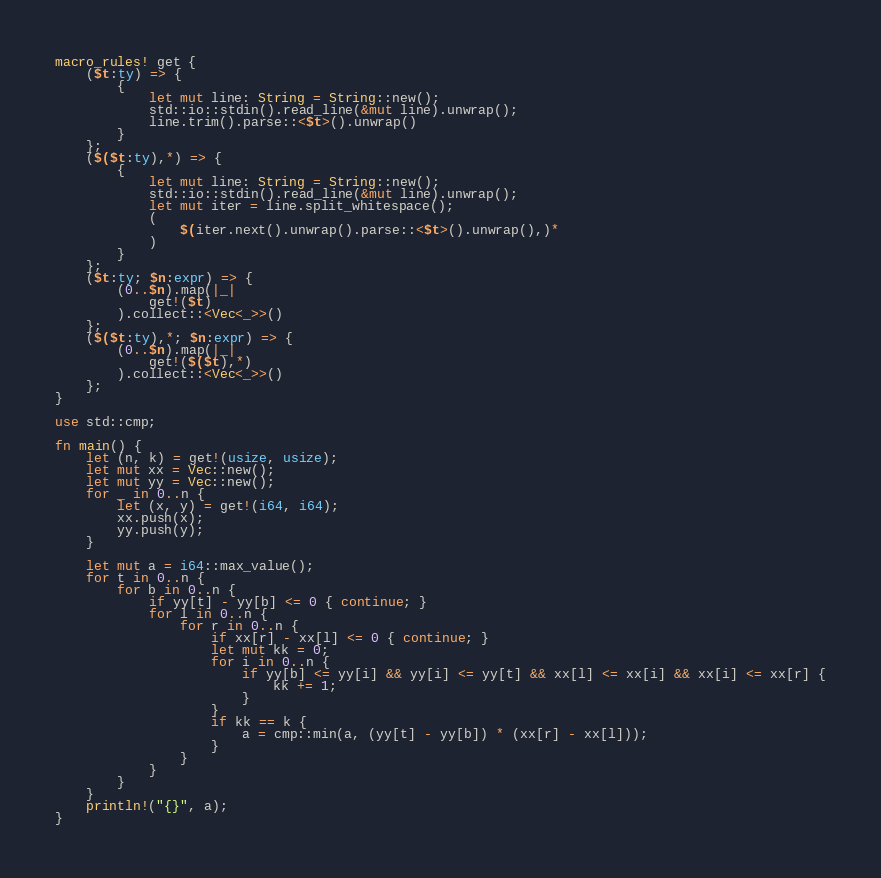<code> <loc_0><loc_0><loc_500><loc_500><_Rust_>macro_rules! get {
    ($t:ty) => {
        {
            let mut line: String = String::new();
            std::io::stdin().read_line(&mut line).unwrap();
            line.trim().parse::<$t>().unwrap()
        }
    };
    ($($t:ty),*) => {
        {
            let mut line: String = String::new();
            std::io::stdin().read_line(&mut line).unwrap();
            let mut iter = line.split_whitespace();
            (
                $(iter.next().unwrap().parse::<$t>().unwrap(),)*
            )
        }
    };
    ($t:ty; $n:expr) => {
        (0..$n).map(|_|
            get!($t)
        ).collect::<Vec<_>>()
    };
    ($($t:ty),*; $n:expr) => {
        (0..$n).map(|_|
            get!($($t),*)
        ).collect::<Vec<_>>()
    };
}

use std::cmp;

fn main() {
    let (n, k) = get!(usize, usize);
    let mut xx = Vec::new();
    let mut yy = Vec::new();
    for _ in 0..n {
        let (x, y) = get!(i64, i64);
        xx.push(x);
        yy.push(y);
    }

    let mut a = i64::max_value();
    for t in 0..n {
        for b in 0..n {
            if yy[t] - yy[b] <= 0 { continue; }
            for l in 0..n {
                for r in 0..n {
                    if xx[r] - xx[l] <= 0 { continue; }
                    let mut kk = 0;
                    for i in 0..n {
                        if yy[b] <= yy[i] && yy[i] <= yy[t] && xx[l] <= xx[i] && xx[i] <= xx[r] {
                            kk += 1;
                        }
                    }
                    if kk == k {
                        a = cmp::min(a, (yy[t] - yy[b]) * (xx[r] - xx[l]));
                    }
                }
            }
        }
    }
    println!("{}", a);
}</code> 